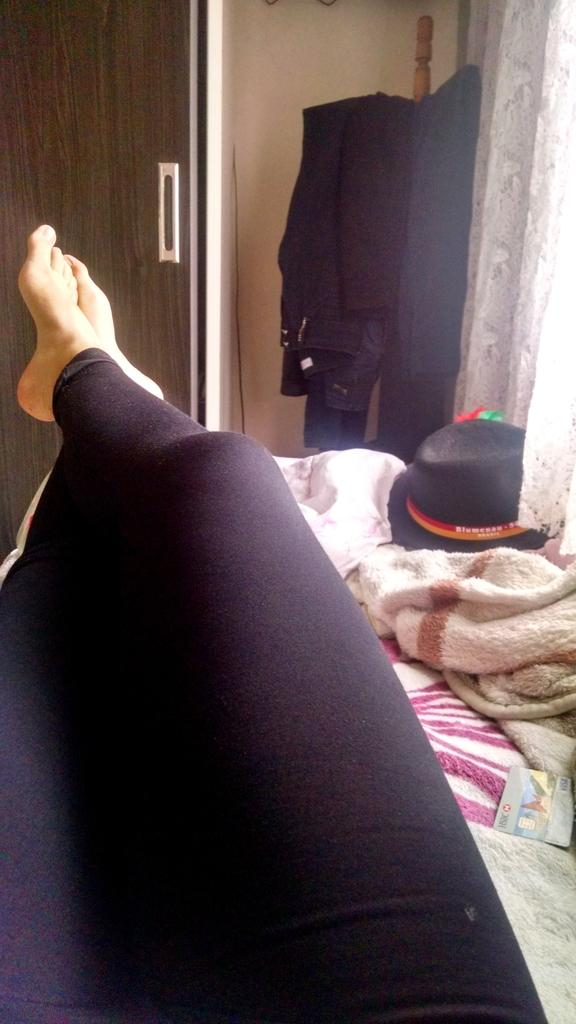What body part is visible in the image? There are a person's legs in the image. What is located on the right side of the image? There is a bed sheet and a cap on the right side of the image. What can be seen in the background of the image? There is a curtain and jeans in the background of the image. What architectural feature is on the left side of the image? There is a door on the left side of the image. What type of recess is visible in the image? There is no recess present in the image. Can you describe the rose in the image? There is no rose present in the image. 